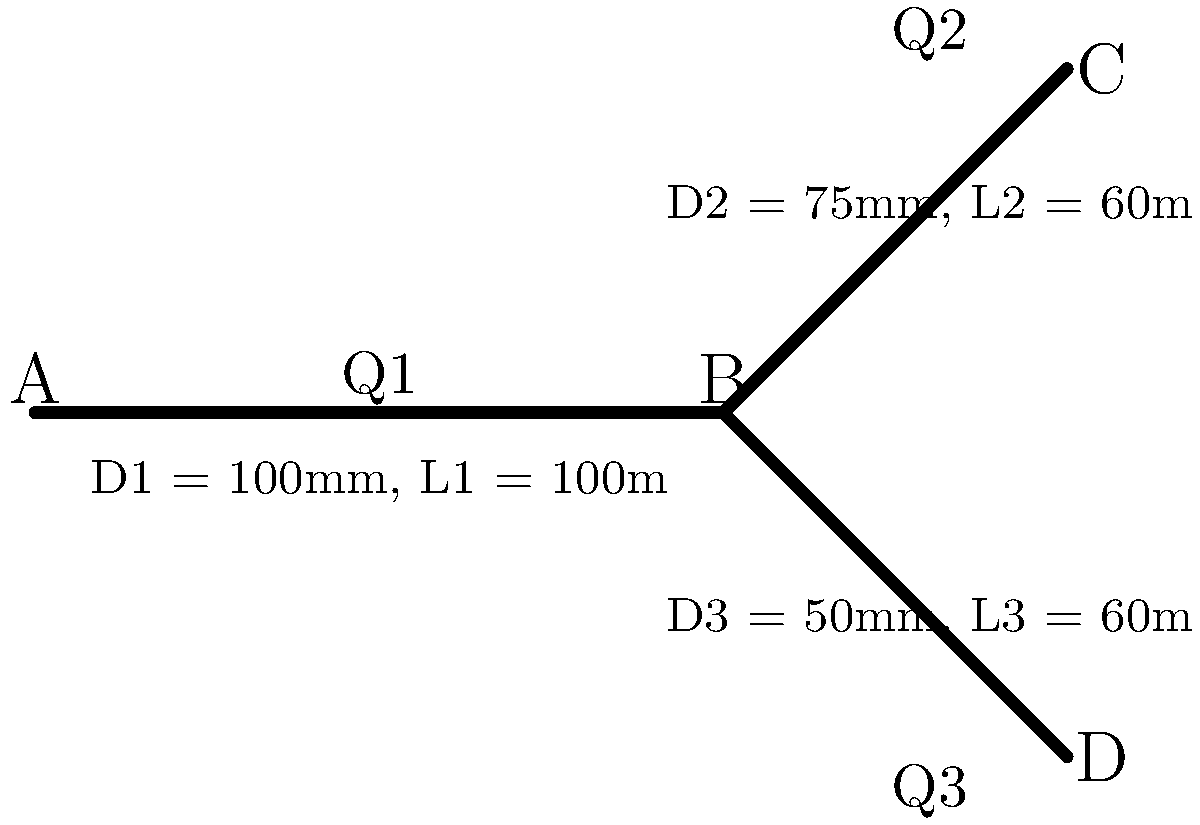In the pipe network shown above, water flows from point A to points C and D through pipes with different diameters and lengths. The total flow rate at point A is 0.05 m³/s. If the head loss in each pipe is proportional to the square of the flow rate and inversely proportional to the fifth power of the diameter, what is the flow rate in pipe 3 (Q3) in L/s? Assume the roughness coefficient is constant for all pipes. To solve this problem, we'll use the concept of flow distribution in parallel pipes. The steps are as follows:

1) First, we need to establish the relationship between flow rates:
   $$Q_1 = Q_2 + Q_3 = 0.05 \text{ m³/s}$$

2) The head loss in each pipe can be expressed as:
   $$h_f \propto \frac{Q^2}{D^5}$$

3) For pipes 2 and 3, the head losses are equal (as they have the same start and end points):
   $$\frac{Q_2^2}{D_2^5} \cdot L_2 = \frac{Q_3^2}{D_3^5} \cdot L_3$$

4) Substituting the given values:
   $$\frac{Q_2^2}{0.075^5} \cdot 60 = \frac{Q_3^2}{0.05^5} \cdot 60$$

5) Simplifying:
   $$\frac{Q_2^2}{0.075^5} = \frac{Q_3^2}{0.05^5}$$

6) This can be rewritten as:
   $$Q_2 = Q_3 \cdot \frac{0.075^{2.5}}{0.05^{2.5}} \approx 3.375 Q_3$$

7) Substituting into the flow rate relationship from step 1:
   $$0.05 = 3.375Q_3 + Q_3 = 4.375Q_3$$

8) Solving for Q3:
   $$Q_3 = \frac{0.05}{4.375} \approx 0.01143 \text{ m³/s}$$

9) Converting to L/s:
   $$Q_3 \approx 11.43 \text{ L/s}$$
Answer: 11.43 L/s 